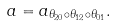Convert formula to latex. <formula><loc_0><loc_0><loc_500><loc_500>a = a _ { \theta _ { 2 0 } \circ \theta _ { 1 2 } \circ \theta _ { 0 1 } } .</formula> 